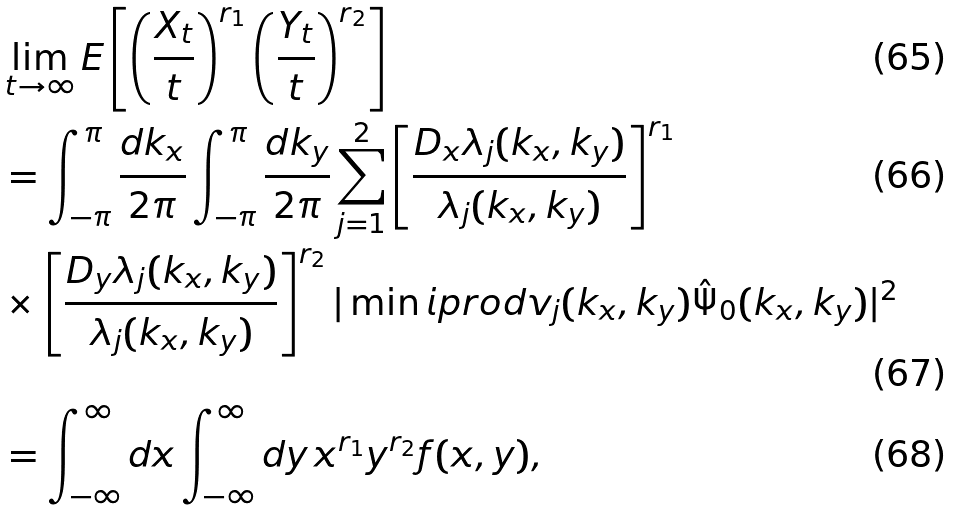Convert formula to latex. <formula><loc_0><loc_0><loc_500><loc_500>& \lim _ { t \rightarrow \infty } E \left [ \left ( \frac { X _ { t } } { t } \right ) ^ { r _ { 1 } } \left ( \frac { Y _ { t } } { t } \right ) ^ { r _ { 2 } } \right ] \\ & = \int _ { - \pi } ^ { \pi } \frac { d k _ { x } } { 2 \pi } \int _ { - \pi } ^ { \pi } \frac { d k _ { y } } { 2 \pi } \sum _ { j = 1 } ^ { 2 } \left [ \frac { D _ { x } \lambda _ { j } ( k _ { x } , k _ { y } ) } { \lambda _ { j } ( k _ { x } , k _ { y } ) } \right ] ^ { r _ { 1 } } \\ & \times \left [ \frac { D _ { y } \lambda _ { j } ( k _ { x } , k _ { y } ) } { \lambda _ { j } ( k _ { x } , k _ { y } ) } \right ] ^ { r _ { 2 } } | \min i p r o d { v _ { j } ( k _ { x } , k _ { y } ) } { \hat { \Psi } _ { 0 } ( k _ { x } , k _ { y } ) } | ^ { 2 } \\ & = \int _ { - \infty } ^ { \infty } d x \int _ { - \infty } ^ { \infty } d y \, x ^ { r _ { 1 } } y ^ { r _ { 2 } } f ( x , y ) ,</formula> 